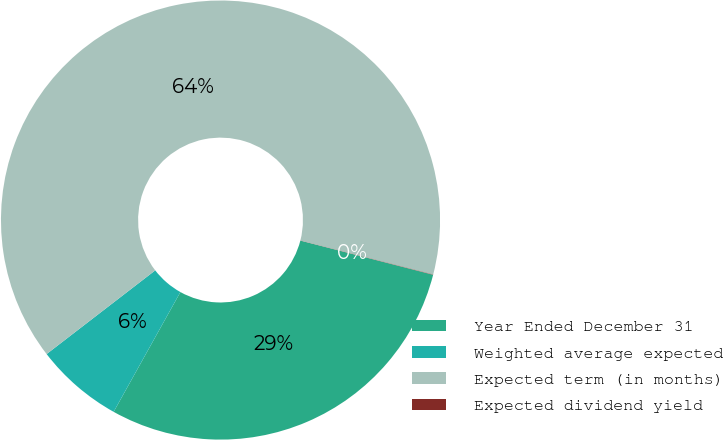Convert chart. <chart><loc_0><loc_0><loc_500><loc_500><pie_chart><fcel>Year Ended December 31<fcel>Weighted average expected<fcel>Expected term (in months)<fcel>Expected dividend yield<nl><fcel>29.08%<fcel>6.46%<fcel>64.44%<fcel>0.02%<nl></chart> 